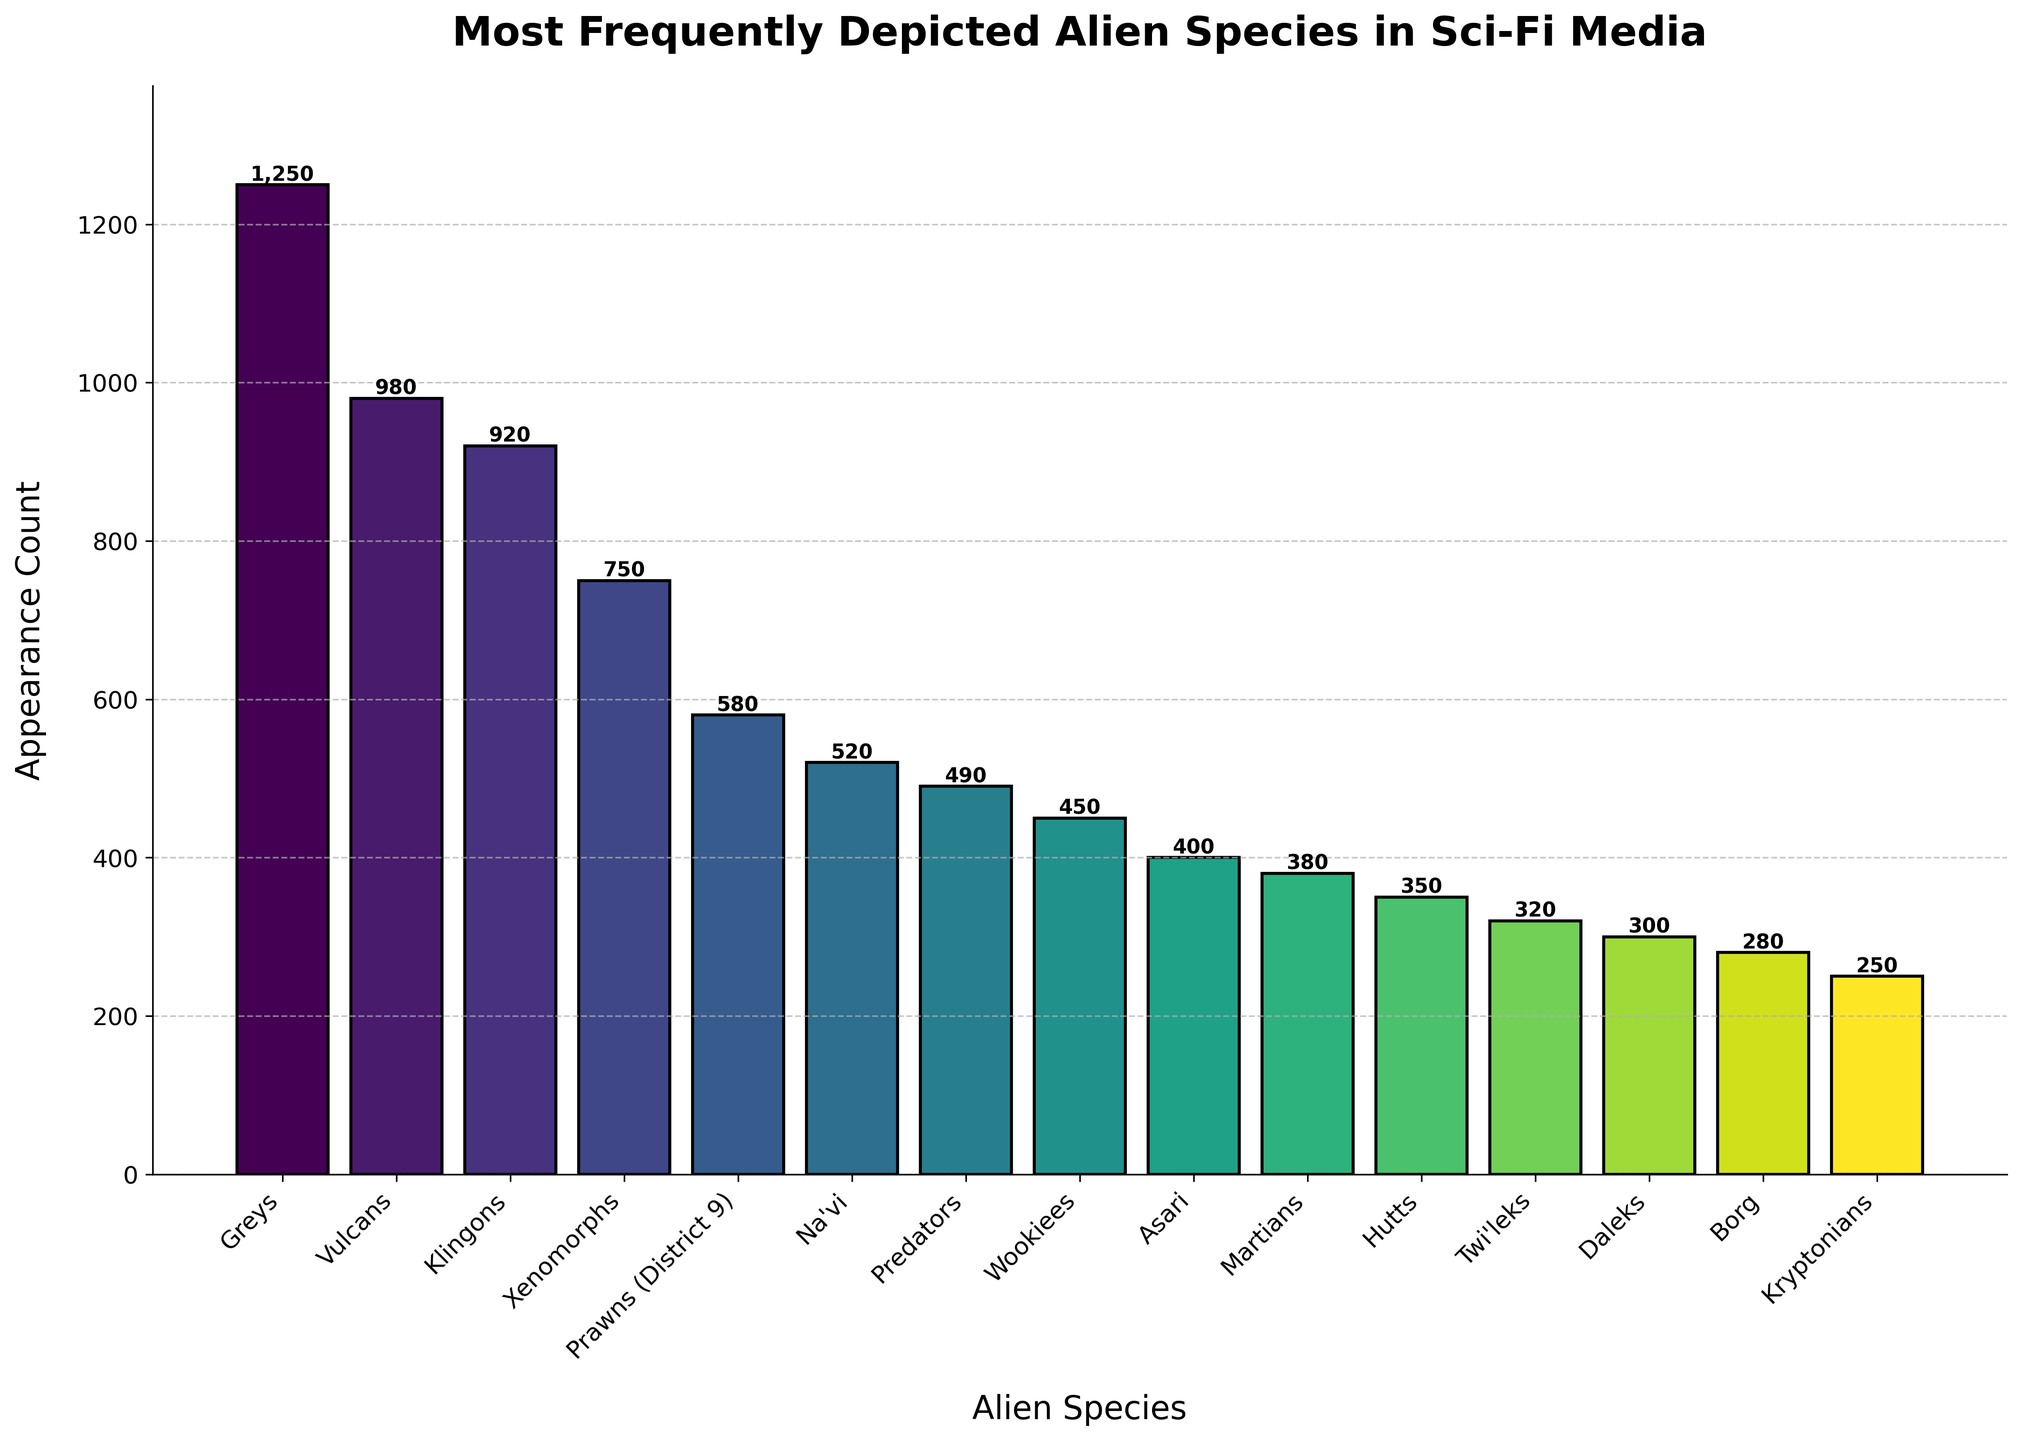What is the total appearance count for all the depicted species combined? By adding the appearance counts for all species: 1250 (Greys) + 980 (Vulcans) + 920 (Klingons) + 750 (Xenomorphs) + 580 (Prawns) + 520 (Na'vi) + 490 (Predators) + 450 (Wookiees) + 400 (Asari) + 380 (Martians) + 350 (Hutts) + 320 (Twi'leks) + 300 (Daleks) + 280 (Borg) + 250 (Kryptonians), the total is 8,220.
Answer: 8,220 Which species has a higher appearance count, Vulcans or Klingons? Referring to the bar chart, Vulcans have an appearance count of 980, whereas Klingons have an appearance count of 920.
Answer: Vulcans How many species have an appearance count greater than 500? By examining the bar heights on the chart, species with appearance counts greater than 500 are Greys, Vulcans, Klingons, Xenomorphs, Prawns, and Na'vi. There are 6 species in total.
Answer: 6 What is the difference in appearance count between the species with the highest and lowest counts? The species with the highest count is Greys (1250), and the species with the lowest count is Kryptonians (250). The difference is 1250 - 250 = 1000.
Answer: 1000 Which species appears exactly 200 times more frequently than Martians? Martians have an appearance count of 380. Prawns have an appearance count of 580, which is exactly 200 more (380 + 200 = 580).
Answer: Prawns What is the average appearance count of the top 3 most frequently depicted species? The top 3 species are Greys (1250), Vulcans (980), and Klingons (920). The total is 1250 + 980 + 920 = 3150. The average is 3150 / 3 = 1050.
Answer: 1050 Identify two species with an appearance count that differs by 250. By comparing the counts, Vulcans (980) and Xenomorphs (750) have a difference of 230, Prawns (580) and Wookiees (450) have a difference of 130, and so on. Kryptonians (250) and Daleks (300) have a difference of 50. Hence, Borg (280) and Kryptonians (250) differ by only 30. Na'vi (520) and Asari (400) have a difference of 120. The calculation is straightforward; validating each pair will work. The closest match is Borg (280) and Kryptonians (250).
Answer: Borg and Kryptonians Which species is represented by the tallest bar in the chart? By visual inspection, the tallest bar corresponds to Greys with an appearance count of 1250.
Answer: Greys 